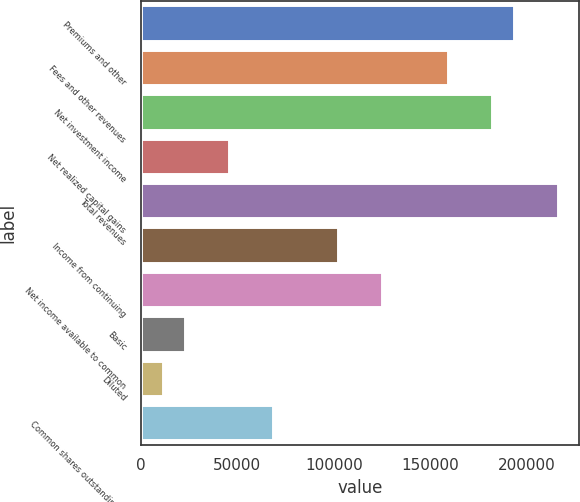Convert chart. <chart><loc_0><loc_0><loc_500><loc_500><bar_chart><fcel>Premiums and other<fcel>Fees and other revenues<fcel>Net investment income<fcel>Net realized capital gains<fcel>Total revenues<fcel>Income from continuing<fcel>Net income available to common<fcel>Basic<fcel>Diluted<fcel>Common shares outstanding at<nl><fcel>193457<fcel>159317<fcel>182077<fcel>45519.7<fcel>216216<fcel>102419<fcel>125178<fcel>22760.1<fcel>11380.3<fcel>68279.2<nl></chart> 